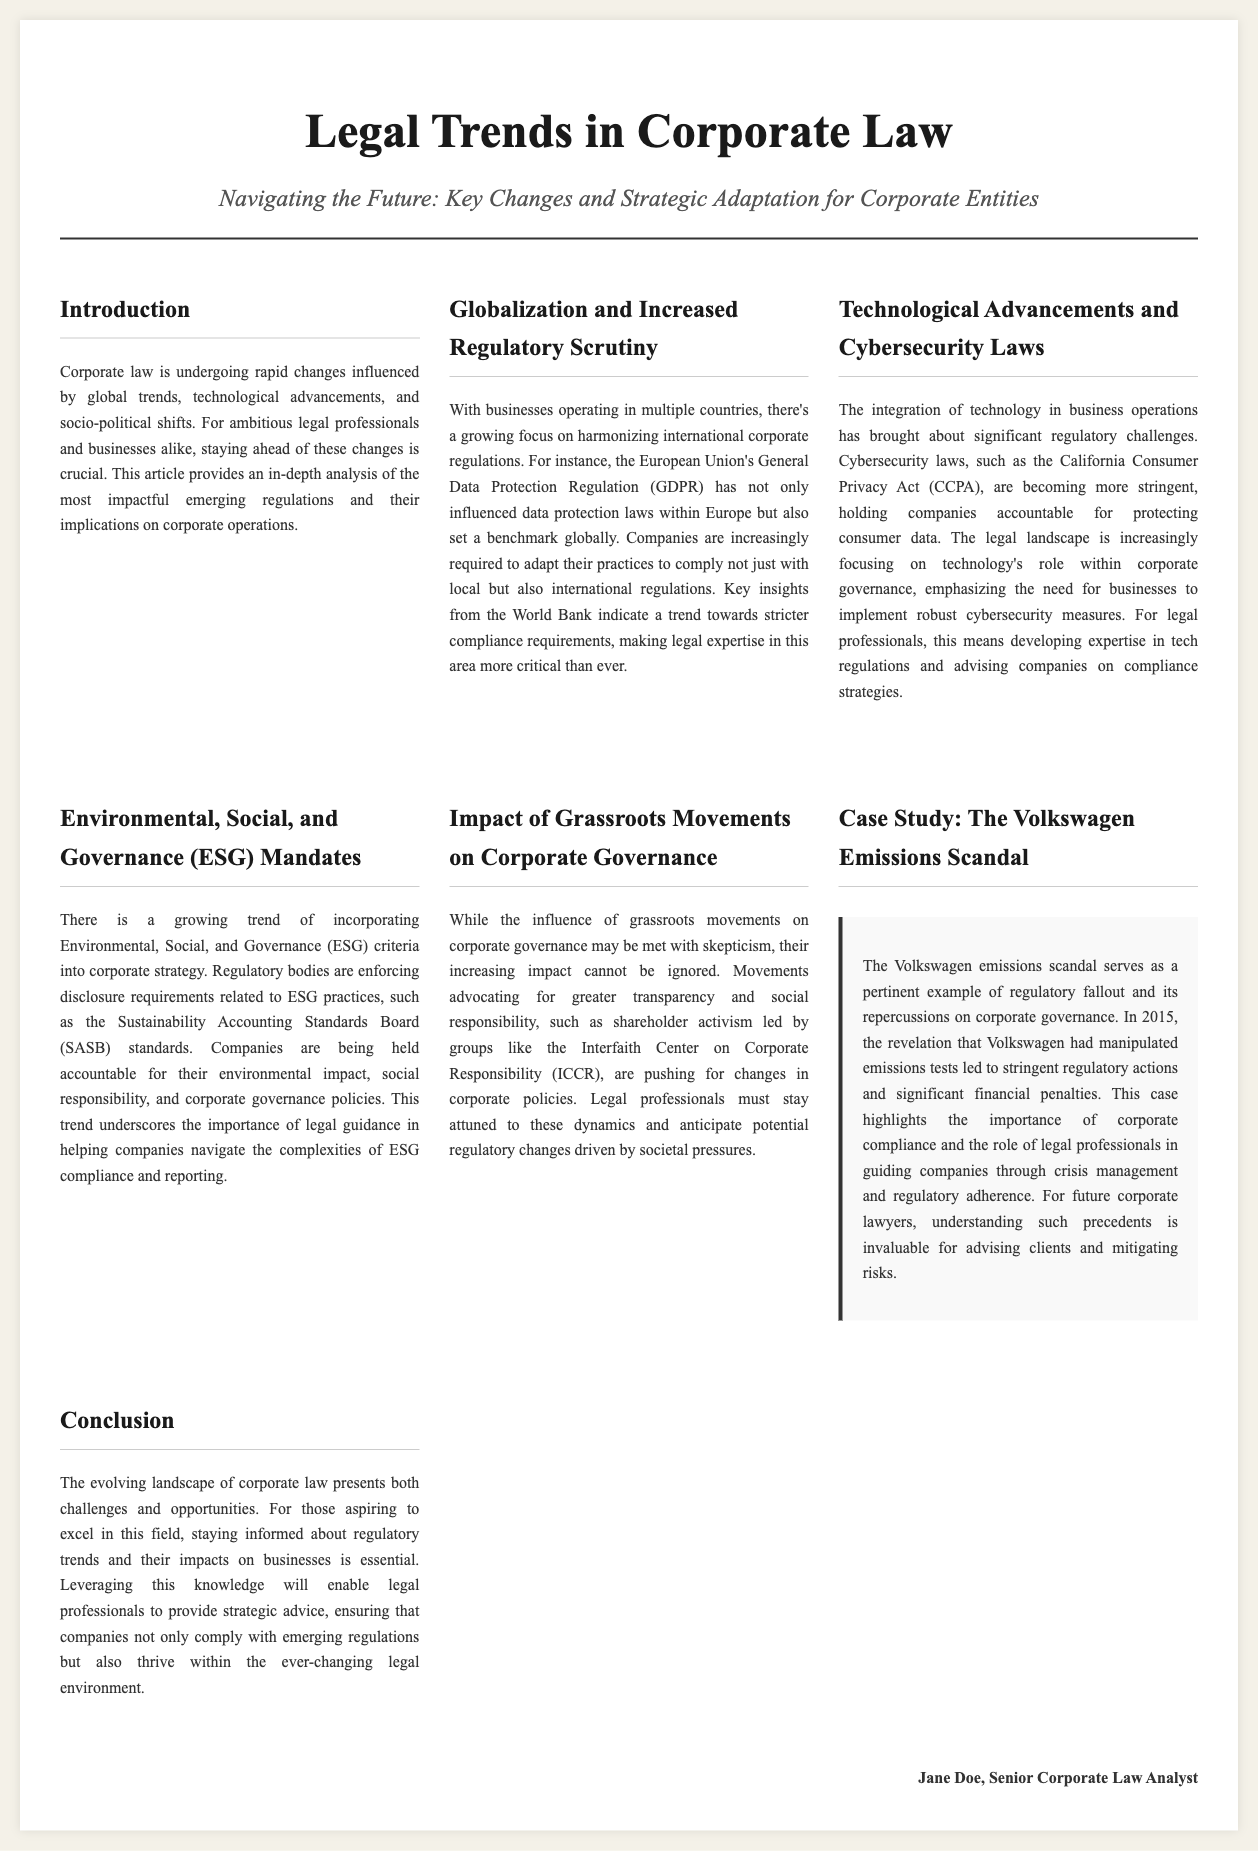what is the title of the document? The title of the document is prominently displayed at the top of the newspaper layout.
Answer: Legal Trends in Corporate Law who is the author of the article? The author's name is provided at the bottom of the content section, identifying who wrote the analysis.
Answer: Jane Doe what regulatory act is mentioned concerning data privacy? A notable regulatory act related to data privacy is discussed under technological advancements and is significant for corporate compliance.
Answer: California Consumer Privacy Act (CCPA) what does ESG stand for in corporate law? The acronym ESG is elaborated on in the section discussing trends in corporate strategy.
Answer: Environmental, Social, and Governance which corporate scandal is used as a case study? A specific case study is highlighted to illustrate the repercussions of corporate negligence and failure.
Answer: The Volkswagen emissions scandal what trend is noted in the section about globalization? This section explains a significant shift impacting businesses and their operations across borders.
Answer: Increased regulatory scrutiny how does the article recommend legal professionals adapt to changes? The document emphasizes the necessity for legal professionals to develop specific expertise due to emerging regulations.
Answer: By acquiring knowledge on regulatory trends and compliance what is the impact of grassroots movements according to the document? This section discusses societal influences on corporate governance and the responses from corporations.
Answer: Increased focus on transparency and social responsibility 